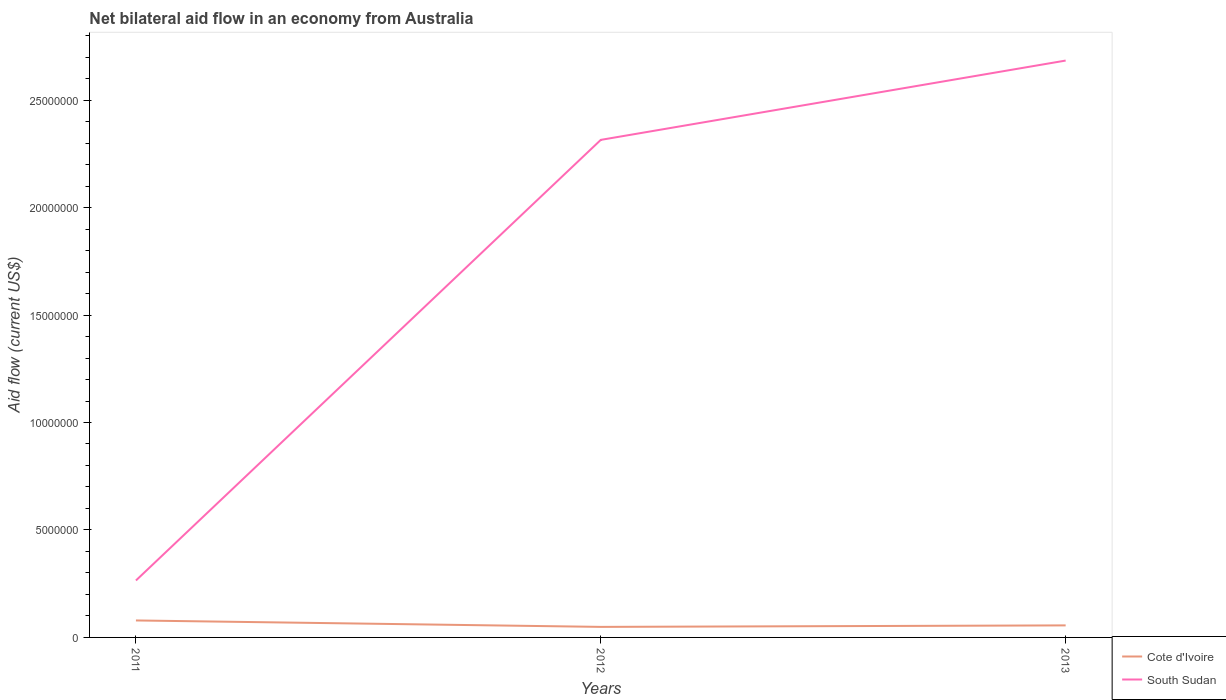How many different coloured lines are there?
Keep it short and to the point. 2. Does the line corresponding to Cote d'Ivoire intersect with the line corresponding to South Sudan?
Give a very brief answer. No. Is the number of lines equal to the number of legend labels?
Provide a succinct answer. Yes. In which year was the net bilateral aid flow in Cote d'Ivoire maximum?
Keep it short and to the point. 2012. What is the total net bilateral aid flow in South Sudan in the graph?
Ensure brevity in your answer.  -3.69e+06. What is the difference between the highest and the second highest net bilateral aid flow in South Sudan?
Offer a terse response. 2.42e+07. What is the difference between the highest and the lowest net bilateral aid flow in Cote d'Ivoire?
Provide a succinct answer. 1. Is the net bilateral aid flow in Cote d'Ivoire strictly greater than the net bilateral aid flow in South Sudan over the years?
Provide a succinct answer. Yes. How many years are there in the graph?
Offer a very short reply. 3. What is the difference between two consecutive major ticks on the Y-axis?
Your answer should be compact. 5.00e+06. Does the graph contain grids?
Your response must be concise. No. What is the title of the graph?
Your response must be concise. Net bilateral aid flow in an economy from Australia. What is the label or title of the X-axis?
Your answer should be compact. Years. What is the Aid flow (current US$) in Cote d'Ivoire in 2011?
Offer a very short reply. 7.90e+05. What is the Aid flow (current US$) of South Sudan in 2011?
Provide a succinct answer. 2.65e+06. What is the Aid flow (current US$) of Cote d'Ivoire in 2012?
Your response must be concise. 4.90e+05. What is the Aid flow (current US$) of South Sudan in 2012?
Provide a succinct answer. 2.32e+07. What is the Aid flow (current US$) of Cote d'Ivoire in 2013?
Provide a succinct answer. 5.60e+05. What is the Aid flow (current US$) in South Sudan in 2013?
Your answer should be very brief. 2.68e+07. Across all years, what is the maximum Aid flow (current US$) of Cote d'Ivoire?
Keep it short and to the point. 7.90e+05. Across all years, what is the maximum Aid flow (current US$) in South Sudan?
Your response must be concise. 2.68e+07. Across all years, what is the minimum Aid flow (current US$) in Cote d'Ivoire?
Give a very brief answer. 4.90e+05. Across all years, what is the minimum Aid flow (current US$) in South Sudan?
Keep it short and to the point. 2.65e+06. What is the total Aid flow (current US$) in Cote d'Ivoire in the graph?
Provide a short and direct response. 1.84e+06. What is the total Aid flow (current US$) in South Sudan in the graph?
Ensure brevity in your answer.  5.26e+07. What is the difference between the Aid flow (current US$) of South Sudan in 2011 and that in 2012?
Ensure brevity in your answer.  -2.05e+07. What is the difference between the Aid flow (current US$) of South Sudan in 2011 and that in 2013?
Make the answer very short. -2.42e+07. What is the difference between the Aid flow (current US$) of Cote d'Ivoire in 2012 and that in 2013?
Keep it short and to the point. -7.00e+04. What is the difference between the Aid flow (current US$) of South Sudan in 2012 and that in 2013?
Your answer should be compact. -3.69e+06. What is the difference between the Aid flow (current US$) of Cote d'Ivoire in 2011 and the Aid flow (current US$) of South Sudan in 2012?
Make the answer very short. -2.24e+07. What is the difference between the Aid flow (current US$) of Cote d'Ivoire in 2011 and the Aid flow (current US$) of South Sudan in 2013?
Your response must be concise. -2.60e+07. What is the difference between the Aid flow (current US$) of Cote d'Ivoire in 2012 and the Aid flow (current US$) of South Sudan in 2013?
Provide a succinct answer. -2.64e+07. What is the average Aid flow (current US$) of Cote d'Ivoire per year?
Keep it short and to the point. 6.13e+05. What is the average Aid flow (current US$) in South Sudan per year?
Provide a short and direct response. 1.75e+07. In the year 2011, what is the difference between the Aid flow (current US$) of Cote d'Ivoire and Aid flow (current US$) of South Sudan?
Ensure brevity in your answer.  -1.86e+06. In the year 2012, what is the difference between the Aid flow (current US$) of Cote d'Ivoire and Aid flow (current US$) of South Sudan?
Ensure brevity in your answer.  -2.27e+07. In the year 2013, what is the difference between the Aid flow (current US$) of Cote d'Ivoire and Aid flow (current US$) of South Sudan?
Give a very brief answer. -2.63e+07. What is the ratio of the Aid flow (current US$) of Cote d'Ivoire in 2011 to that in 2012?
Your response must be concise. 1.61. What is the ratio of the Aid flow (current US$) of South Sudan in 2011 to that in 2012?
Give a very brief answer. 0.11. What is the ratio of the Aid flow (current US$) of Cote d'Ivoire in 2011 to that in 2013?
Your answer should be compact. 1.41. What is the ratio of the Aid flow (current US$) of South Sudan in 2011 to that in 2013?
Keep it short and to the point. 0.1. What is the ratio of the Aid flow (current US$) of Cote d'Ivoire in 2012 to that in 2013?
Your response must be concise. 0.88. What is the ratio of the Aid flow (current US$) of South Sudan in 2012 to that in 2013?
Ensure brevity in your answer.  0.86. What is the difference between the highest and the second highest Aid flow (current US$) in Cote d'Ivoire?
Keep it short and to the point. 2.30e+05. What is the difference between the highest and the second highest Aid flow (current US$) of South Sudan?
Give a very brief answer. 3.69e+06. What is the difference between the highest and the lowest Aid flow (current US$) of South Sudan?
Keep it short and to the point. 2.42e+07. 